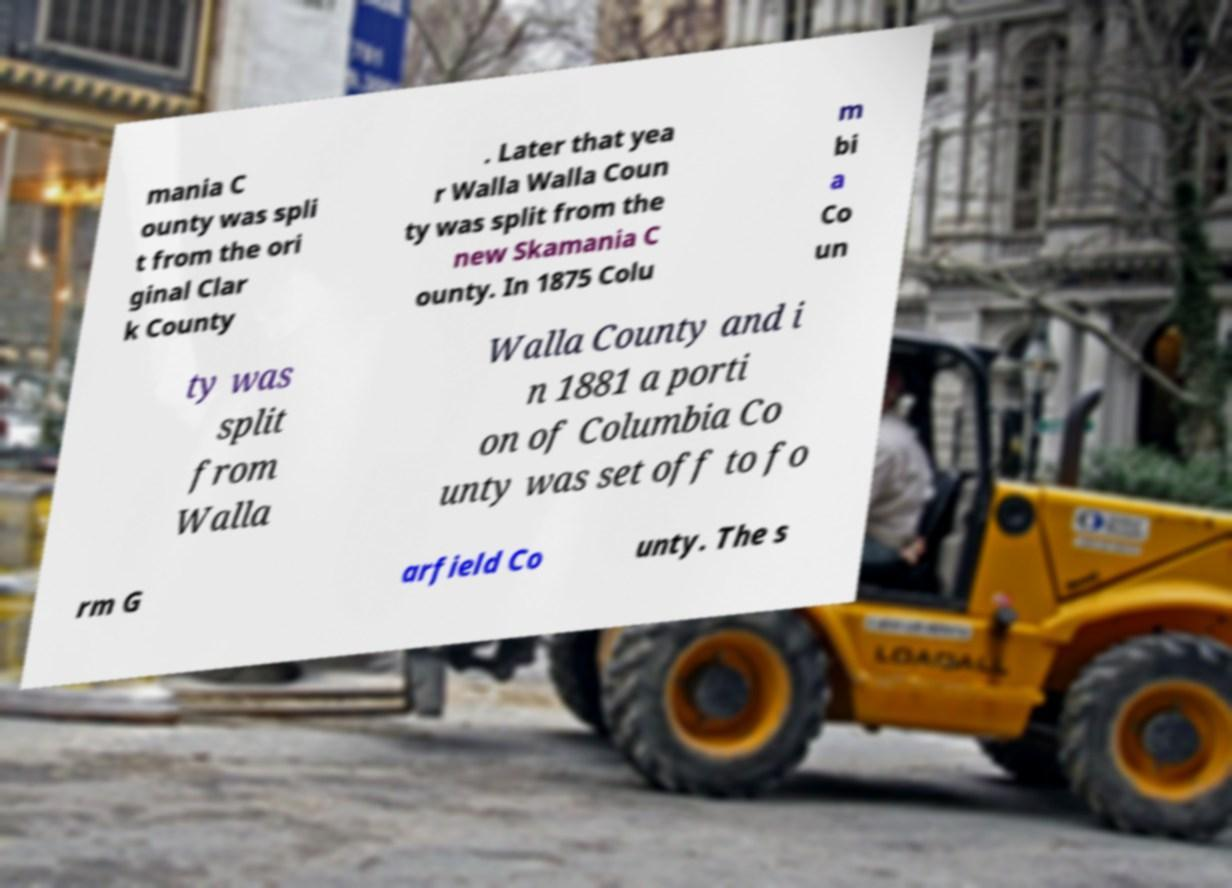Could you assist in decoding the text presented in this image and type it out clearly? mania C ounty was spli t from the ori ginal Clar k County . Later that yea r Walla Walla Coun ty was split from the new Skamania C ounty. In 1875 Colu m bi a Co un ty was split from Walla Walla County and i n 1881 a porti on of Columbia Co unty was set off to fo rm G arfield Co unty. The s 